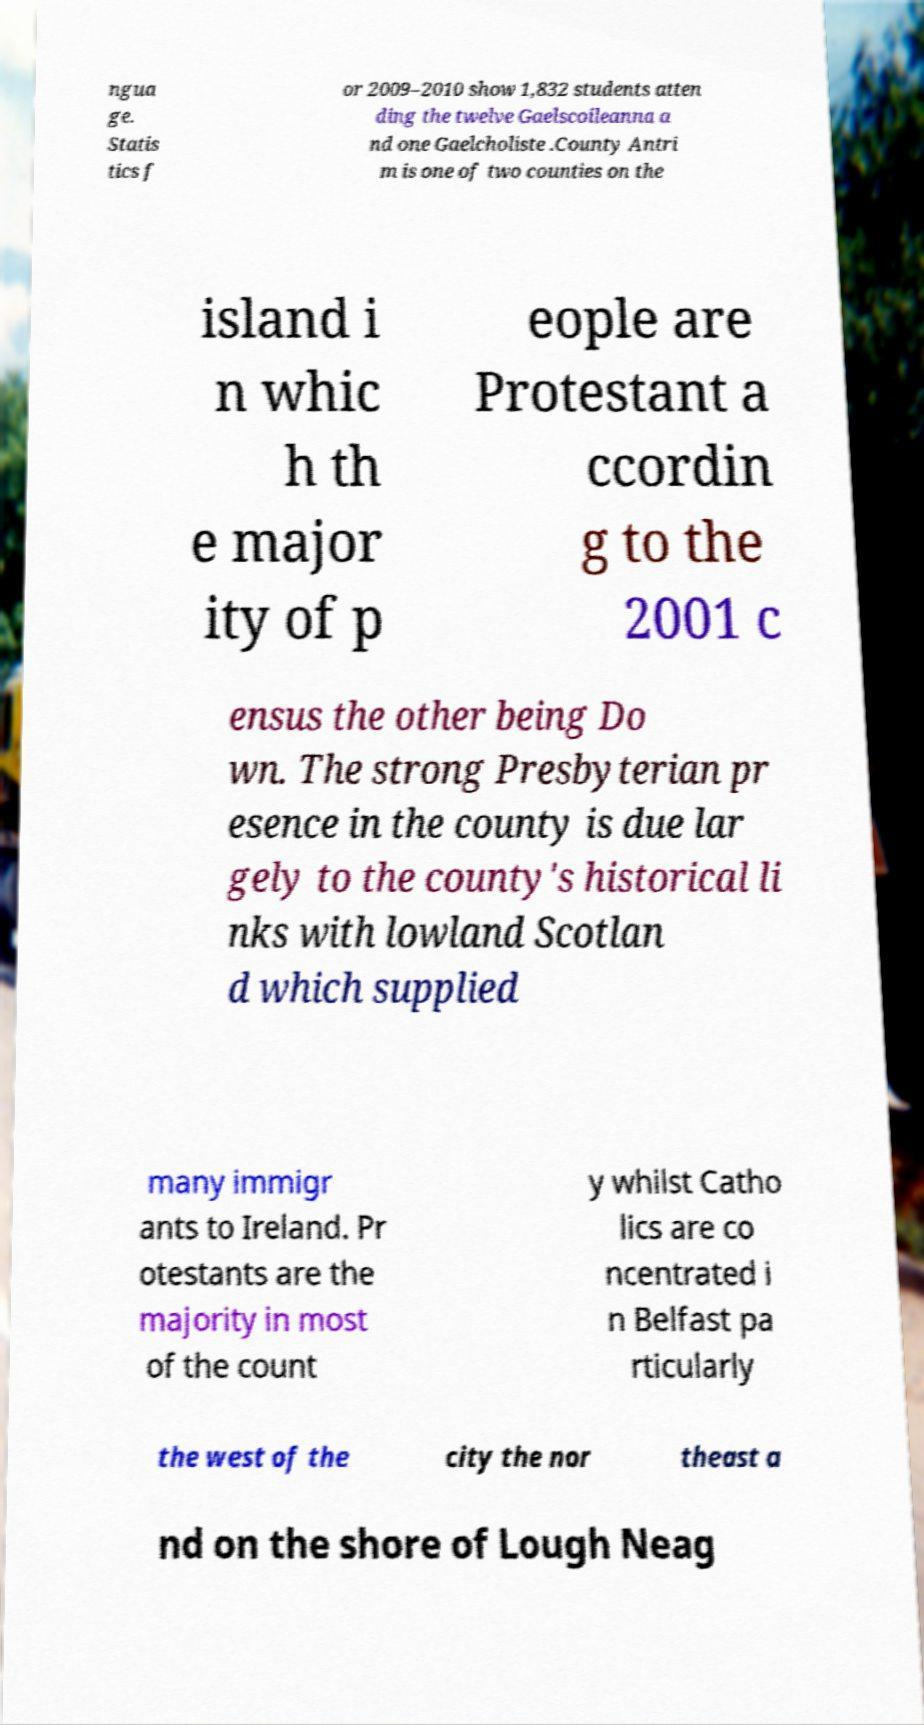Please identify and transcribe the text found in this image. ngua ge. Statis tics f or 2009–2010 show 1,832 students atten ding the twelve Gaelscoileanna a nd one Gaelcholiste .County Antri m is one of two counties on the island i n whic h th e major ity of p eople are Protestant a ccordin g to the 2001 c ensus the other being Do wn. The strong Presbyterian pr esence in the county is due lar gely to the county's historical li nks with lowland Scotlan d which supplied many immigr ants to Ireland. Pr otestants are the majority in most of the count y whilst Catho lics are co ncentrated i n Belfast pa rticularly the west of the city the nor theast a nd on the shore of Lough Neag 